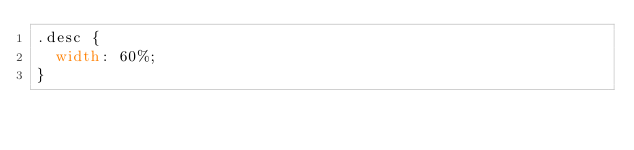Convert code to text. <code><loc_0><loc_0><loc_500><loc_500><_CSS_>.desc {
  width: 60%;
}
</code> 